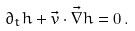<formula> <loc_0><loc_0><loc_500><loc_500>\partial _ { t } h + \vec { v } \cdot \vec { \nabla } h = 0 \, .</formula> 